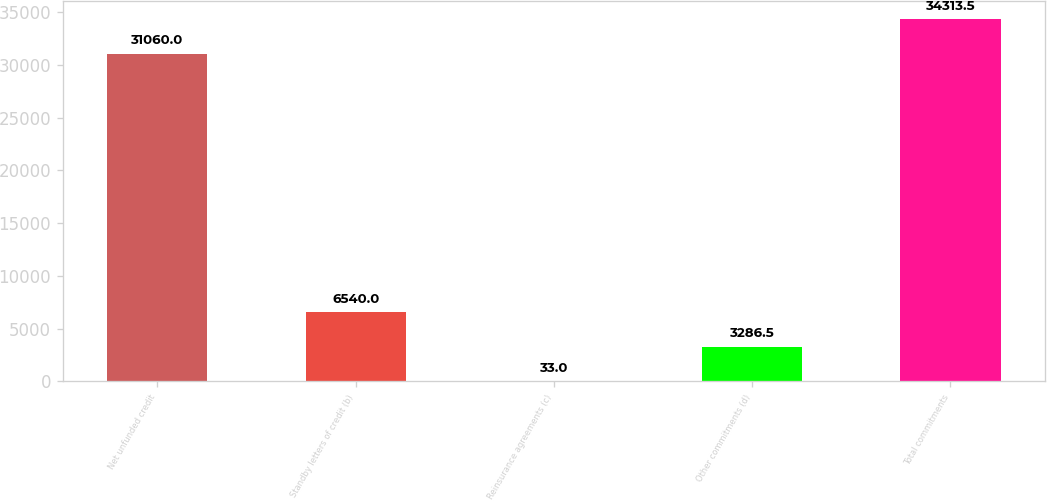<chart> <loc_0><loc_0><loc_500><loc_500><bar_chart><fcel>Net unfunded credit<fcel>Standby letters of credit (b)<fcel>Reinsurance agreements (c)<fcel>Other commitments (d)<fcel>Total commitments<nl><fcel>31060<fcel>6540<fcel>33<fcel>3286.5<fcel>34313.5<nl></chart> 